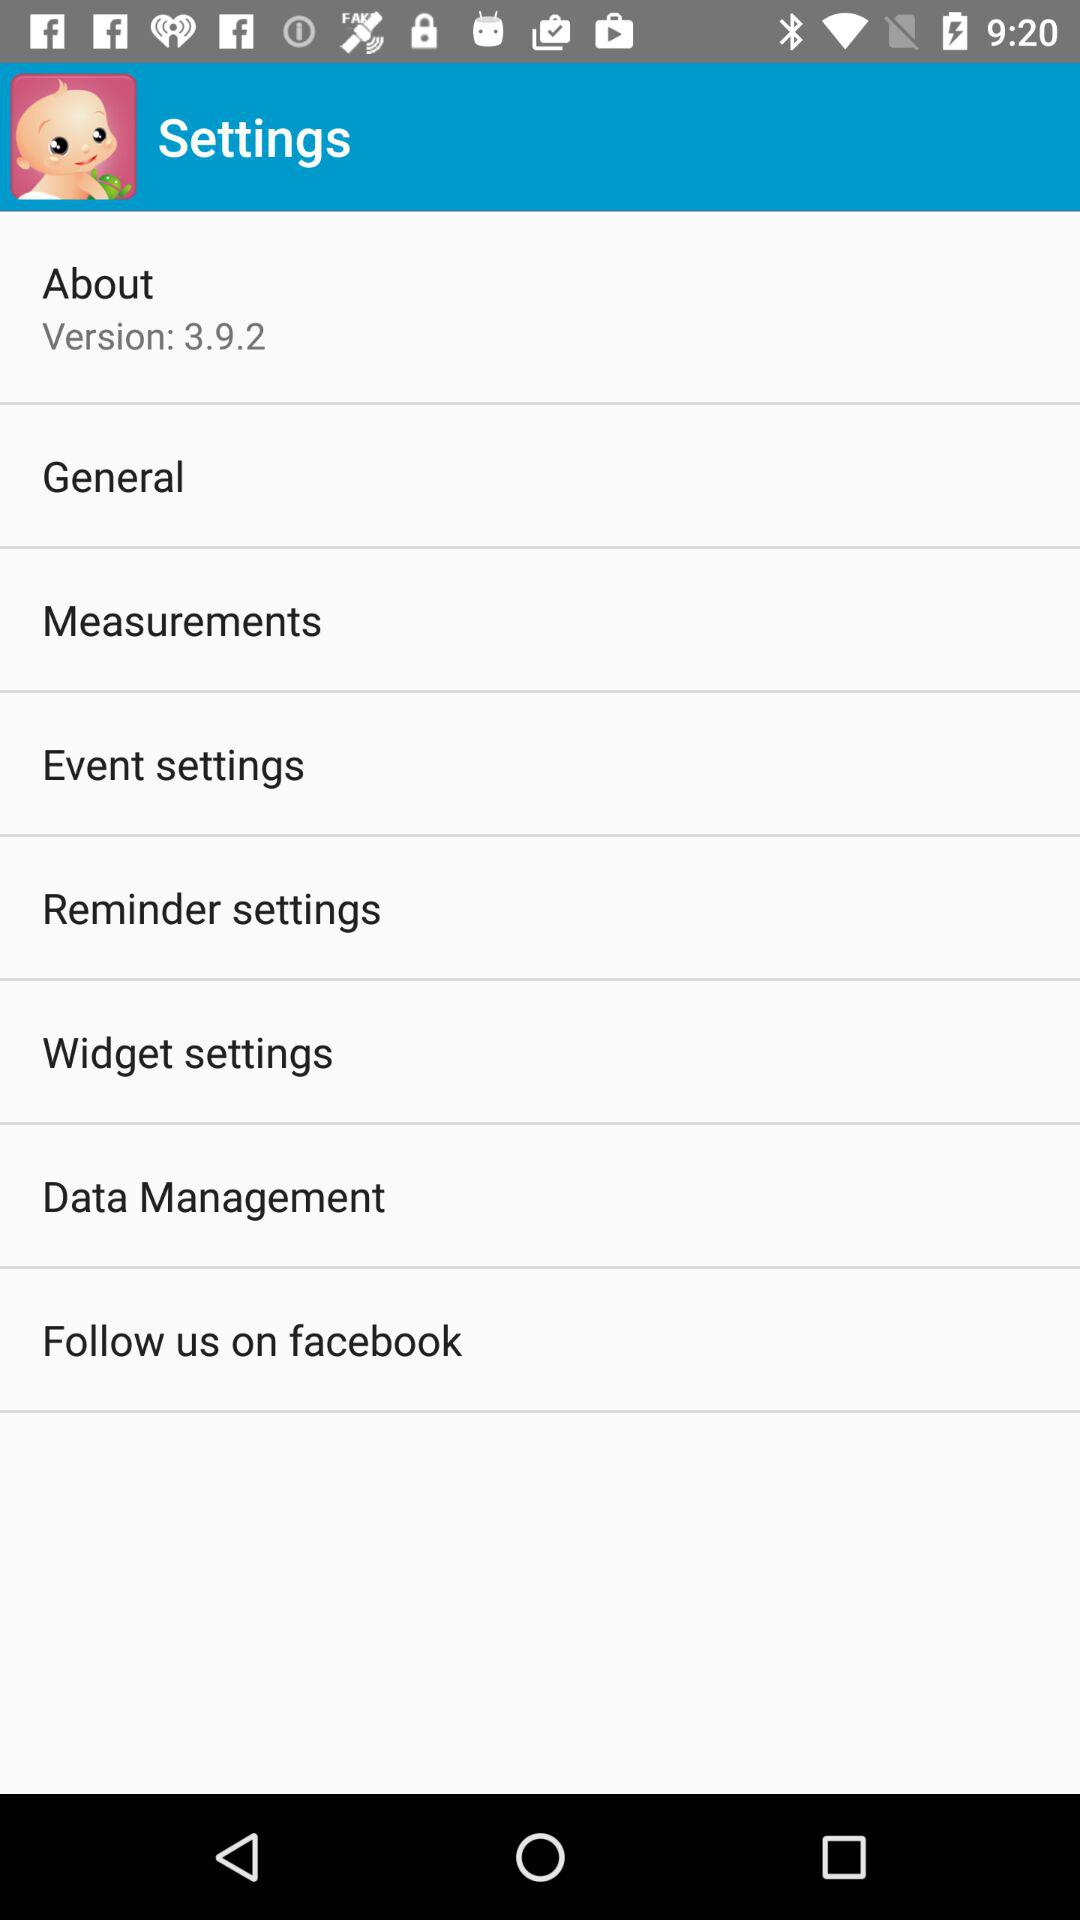How many settings are there?
Answer the question using a single word or phrase. 8 